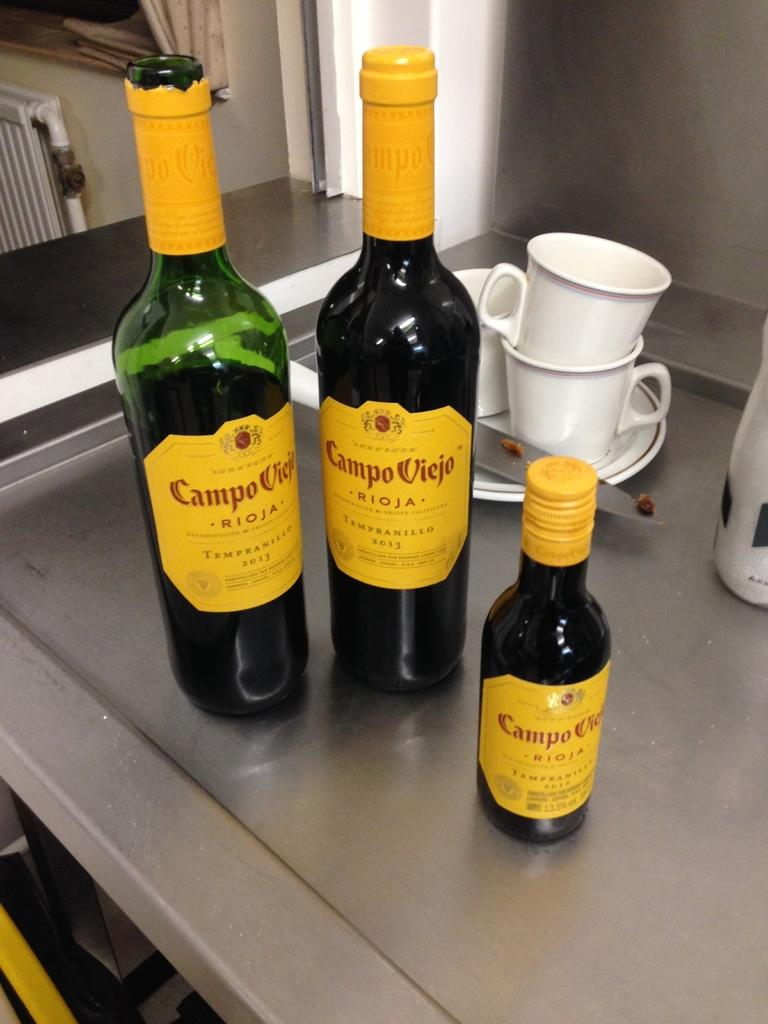<image>
Give a short and clear explanation of the subsequent image. the word campo that is on a bottle 